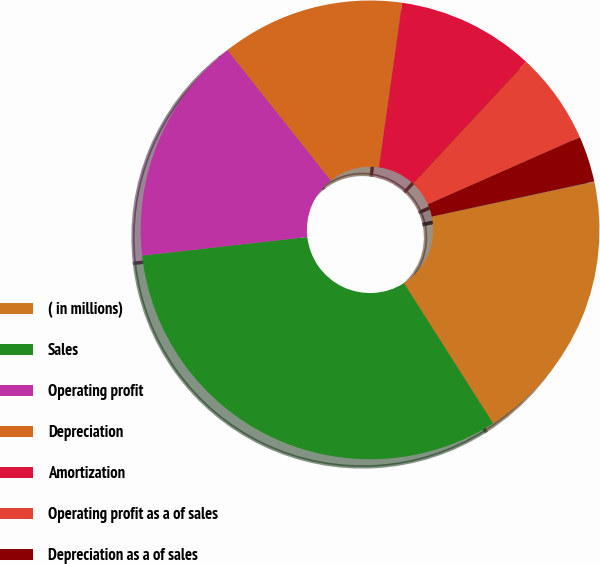Convert chart to OTSL. <chart><loc_0><loc_0><loc_500><loc_500><pie_chart><fcel>( in millions)<fcel>Sales<fcel>Operating profit<fcel>Depreciation<fcel>Amortization<fcel>Operating profit as a of sales<fcel>Depreciation as a of sales<fcel>Amortization as a of sales<nl><fcel>19.34%<fcel>32.23%<fcel>16.12%<fcel>12.9%<fcel>9.68%<fcel>6.46%<fcel>3.24%<fcel>0.02%<nl></chart> 